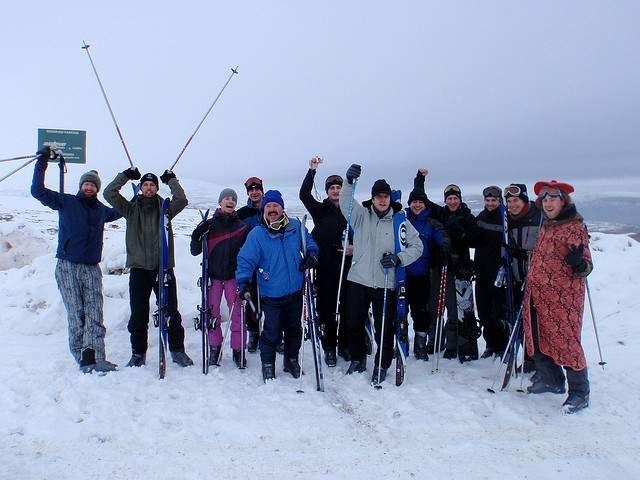Describe the objects in this image and their specific colors. I can see people in lavender, black, maroon, brown, and purple tones, people in lavender, black, blue, navy, and darkblue tones, people in lavender, black, navy, gray, and darkblue tones, people in lavender, navy, black, and gray tones, and people in lavender, black, and gray tones in this image. 